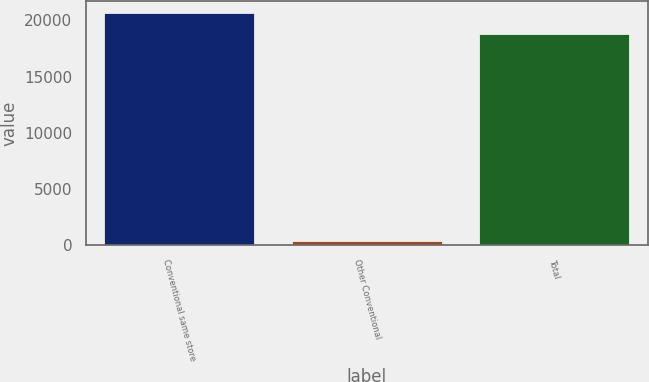Convert chart. <chart><loc_0><loc_0><loc_500><loc_500><bar_chart><fcel>Conventional same store<fcel>Other Conventional<fcel>Total<nl><fcel>20688.8<fcel>407<fcel>18808<nl></chart> 